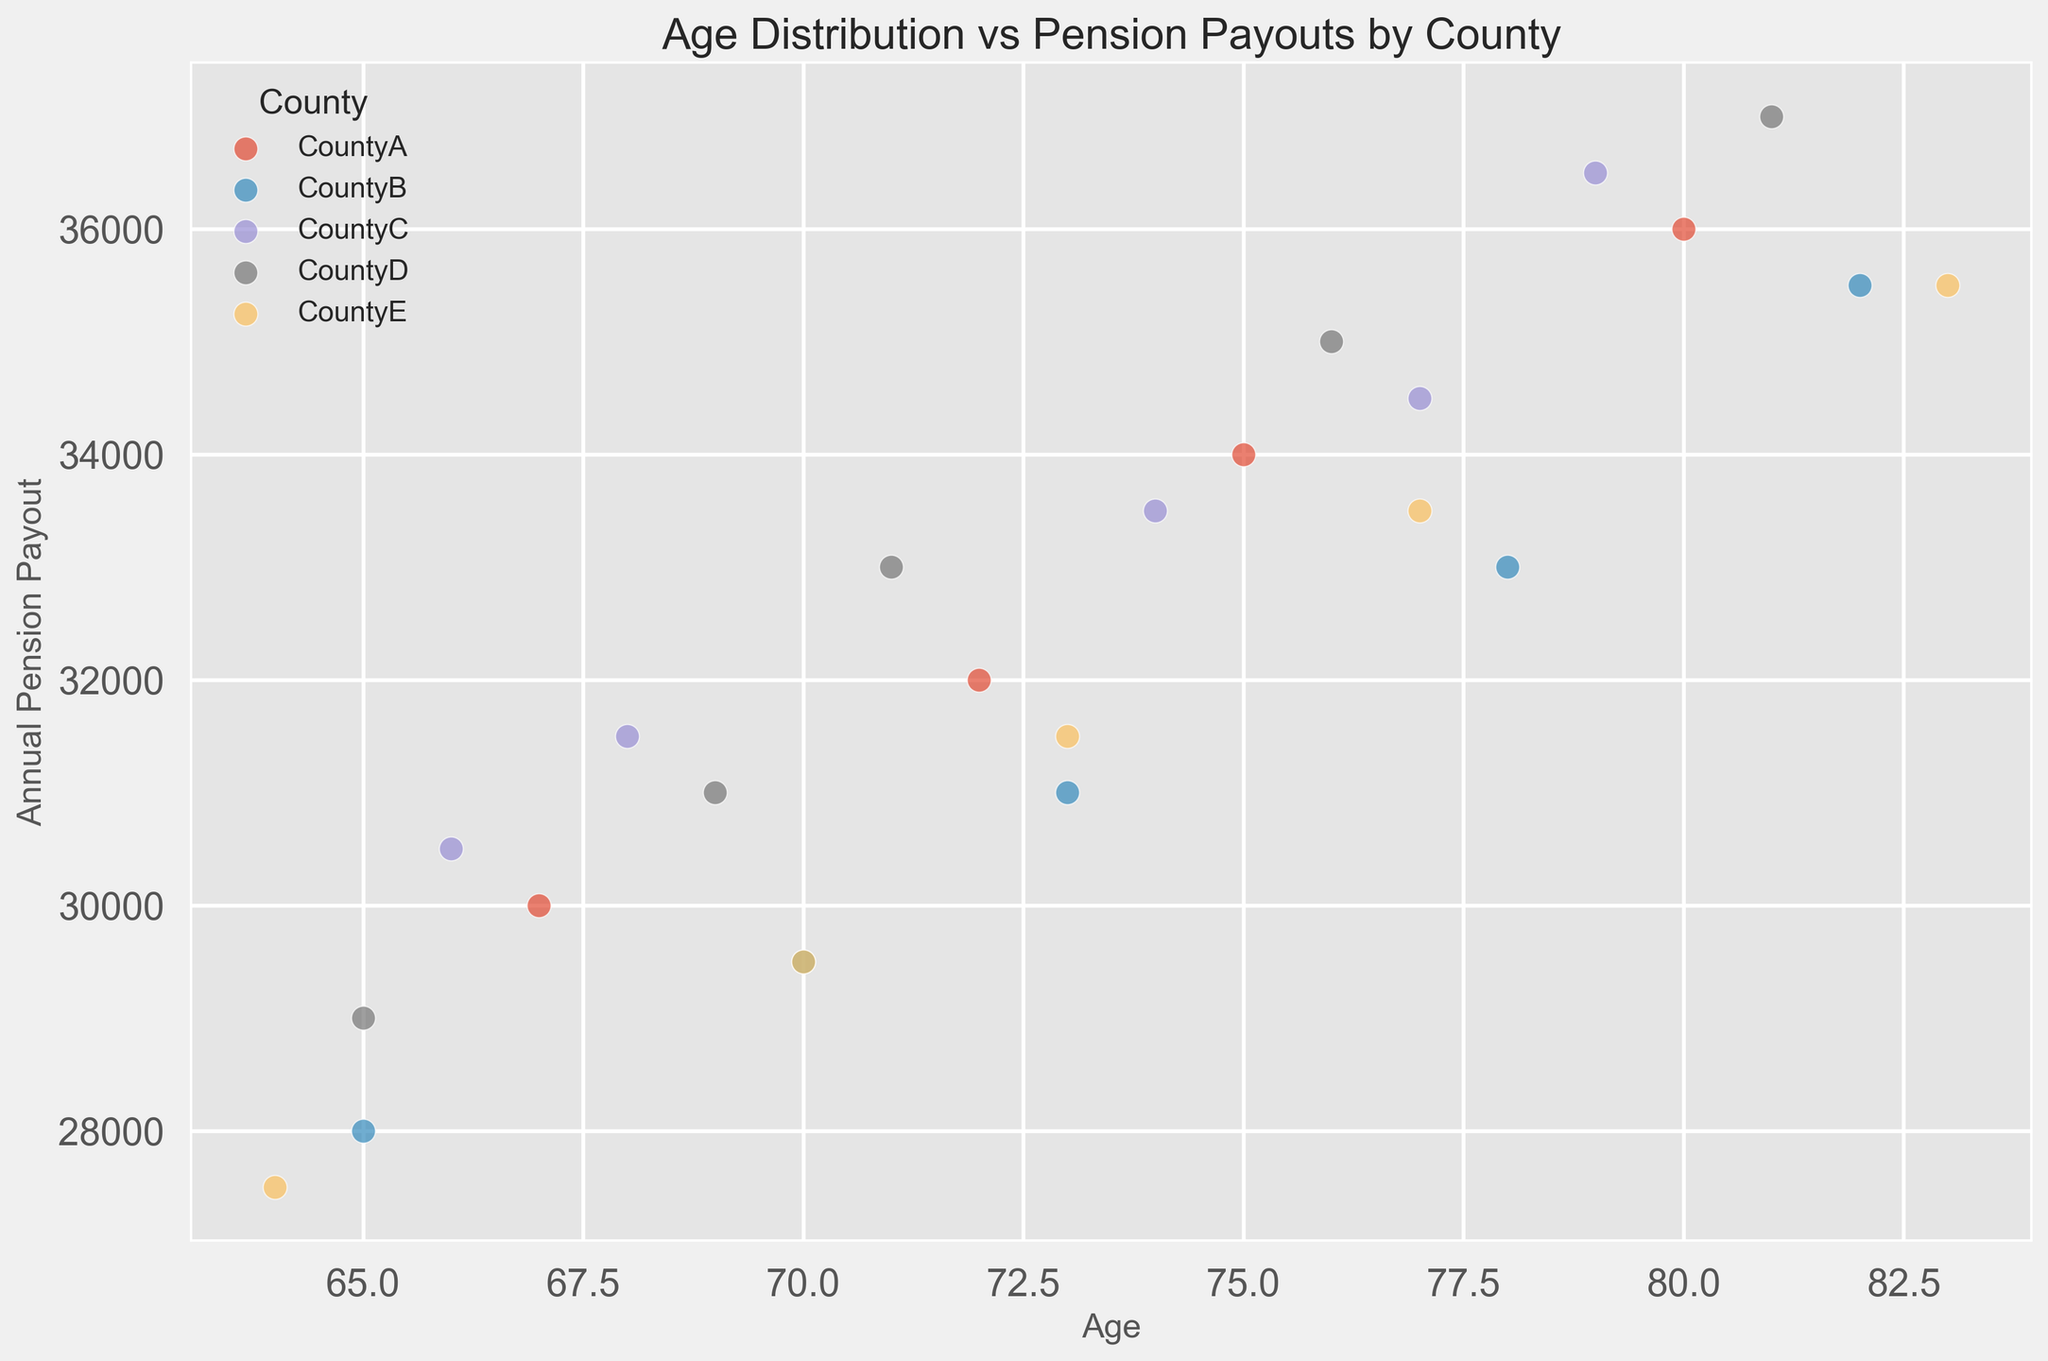What's the average annual pension payout for beneficiaries in CountyA? To find the average annual pension payout for CountyA, sum the pension payouts and divide by the number of data points: (30000 + 32000 + 34000 + 36000) = 132000; 132000/4 = 33000
Answer: 33000 Which county has the highest annual pension payout for any age group? To determine the county with the highest payout, look for the largest value on the y-axis and identify its corresponding data point. The highest payout is 37000, which corresponds to CountyD.
Answer: CountyD What is the difference in the annual pension payout between the oldest and youngest beneficiaries in CountyB? The payout for the oldest age (82) in CountyB is 35500, and for the youngest age (65) is 28000. The difference is 35500 - 28000 = 7500
Answer: 7500 Which county shows the most variation in annual pension payouts? To determine the most variation, visually inspect which county has the most spread-out points on the y-axis. CountyE shows significant variation with payouts ranging from 27500 to 35500
Answer: CountyE What is the median age of pension beneficiaries in CountyE? The ages for CountyE's beneficiaries are 64, 70, 73, 77, 83. The median age is the middle value when the ages are ordered, which is 73
Answer: 73 Compare annual pension payouts at age 70 across all counties. Which county provides the highest payout? For age 70, the payouts are: CountyB (29500), CountyE (29500), and CountyD (31000). CountyD offers the highest payout at this age.
Answer: CountyD Are there any outliers in the age distribution of pension beneficiaries for CountyC? CountyC's ages range from 66 to 79. To find outliers, look for any ages significantly less or greater than this range compared to other counties. CountyC's ages are within a normal range, showing no significant outliers.
Answer: No What is the average annual pension payout for all beneficiaries aged 75 and older across all counties? The beneficiaries aged 75 and older are: (75, 34000), (80, 36000) in CountyA; (78, 33000), (82, 35500) in CountyB; (77, 34500), (79, 36500) in CountyC; (76, 35000), (81, 37000) in CountyD; (77, 33500), (83, 35500) in CountyE. Average payout = (34000 + 36000 + 33000 + 35500 + 34500 + 36500 + 35000 + 37000 + 33500 + 35500) / 10 = 35000
Answer: 35000 Which county has the smallest range of annual pension payouts? The smallest range indicates the least spread in the payouts. Visually observing the scatter plot, CountyB's payouts range from 28000 to 35500 (7500 difference), and other counties have wider ranges. Therefore, CountyB has the smallest range.
Answer: CountyB 